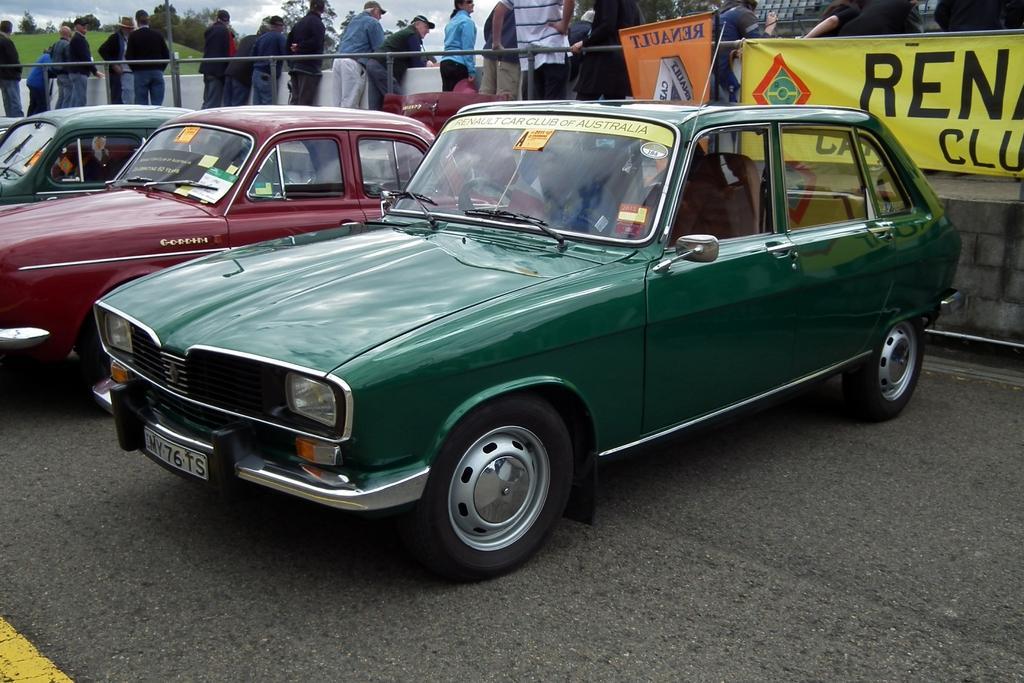Describe this image in one or two sentences. In this image there are cars on the road, in the background there is a fencing to that fencing there are banners, on that banners there is some text and people standing behind the fencing and there are trees. 